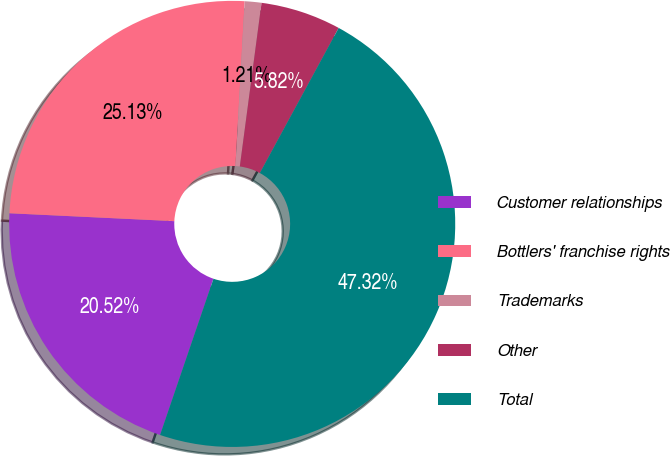<chart> <loc_0><loc_0><loc_500><loc_500><pie_chart><fcel>Customer relationships<fcel>Bottlers' franchise rights<fcel>Trademarks<fcel>Other<fcel>Total<nl><fcel>20.52%<fcel>25.13%<fcel>1.21%<fcel>5.82%<fcel>47.32%<nl></chart> 